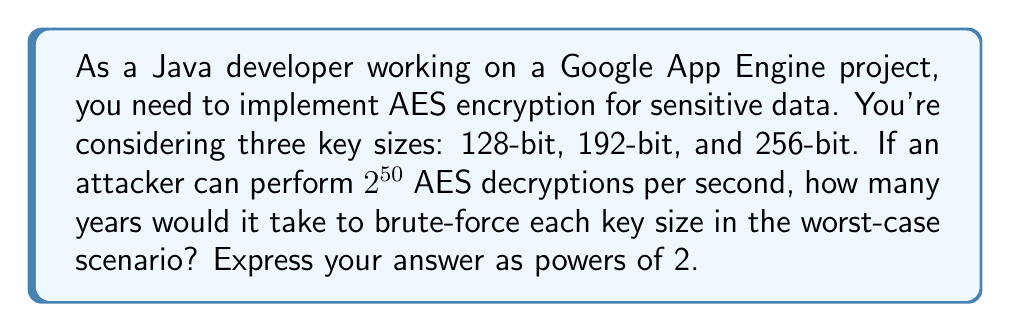Can you answer this question? Let's approach this step-by-step:

1) First, we need to calculate the total number of possible keys for each key size:
   - 128-bit: $2^{128}$ possible keys
   - 192-bit: $2^{192}$ possible keys
   - 256-bit: $2^{256}$ possible keys

2) In the worst-case scenario, the attacker would need to try all possible keys. On average, they would find the correct key after trying half of all possibilities, but we'll consider the worst case.

3) The attacker can perform $2^{50}$ decryptions per second. Let's calculate how many seconds it would take for each key size:

   For 128-bit:
   $$\frac{2^{128}}{2^{50}} = 2^{128-50} = 2^{78} \text{ seconds}$$

   For 192-bit:
   $$\frac{2^{192}}{2^{50}} = 2^{192-50} = 2^{142} \text{ seconds}$$

   For 256-bit:
   $$\frac{2^{256}}{2^{50}} = 2^{256-50} = 2^{206} \text{ seconds}$$

4) Now, let's convert seconds to years. There are approximately $31,536,000 = 2^{24.9}$ seconds in a year.

   For 128-bit:
   $$\frac{2^{78}}{2^{24.9}} \approx 2^{53.1} \text{ years}$$

   For 192-bit:
   $$\frac{2^{142}}{2^{24.9}} \approx 2^{117.1} \text{ years}$$

   For 256-bit:
   $$\frac{2^{206}}{2^{24.9}} \approx 2^{181.1} \text{ years}$$

5) Rounding to the nearest power of 2:
   - 128-bit: $2^{53}$ years
   - 192-bit: $2^{117}$ years
   - 256-bit: $2^{181}$ years
Answer: $2^{53}$, $2^{117}$, $2^{181}$ years 